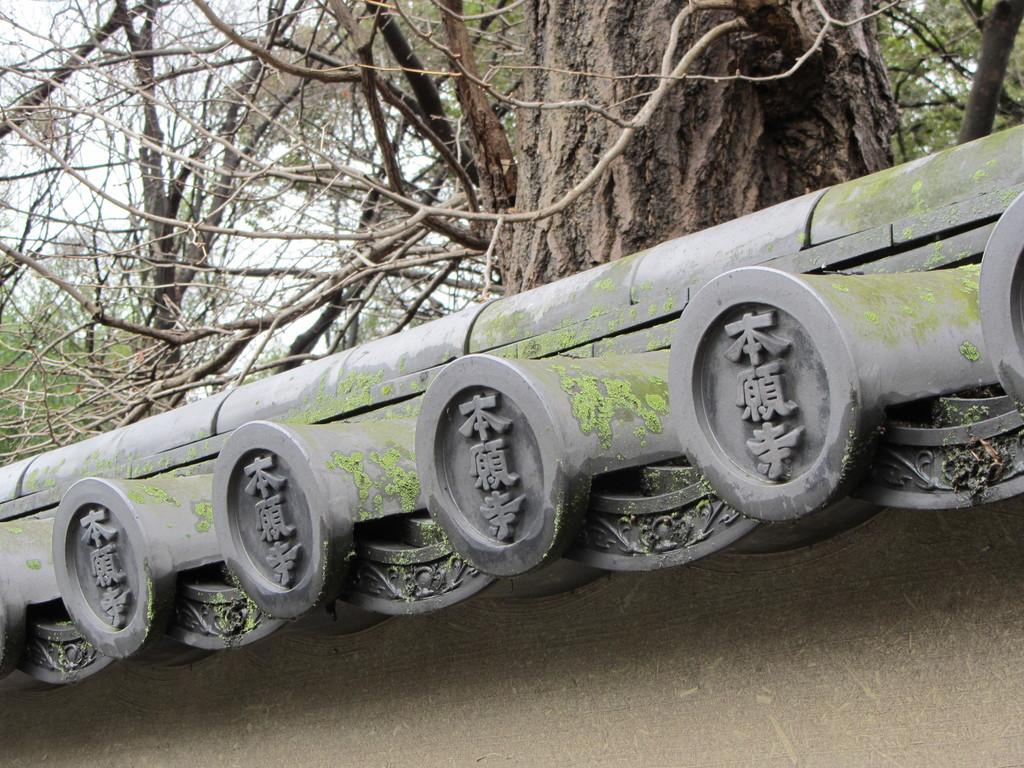Where was the image taken? The image was taken outdoors. What can be seen at the bottom of the image? There is a wall with an architecture at the bottom of the image. What is visible at the top of the image? There are trees at the top of the image. What song is being played in the background of the image? There is no information about any song being played in the image, as it only shows a wall with architecture and trees. 